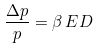Convert formula to latex. <formula><loc_0><loc_0><loc_500><loc_500>\frac { \Delta p } { p } = \beta \, E D</formula> 